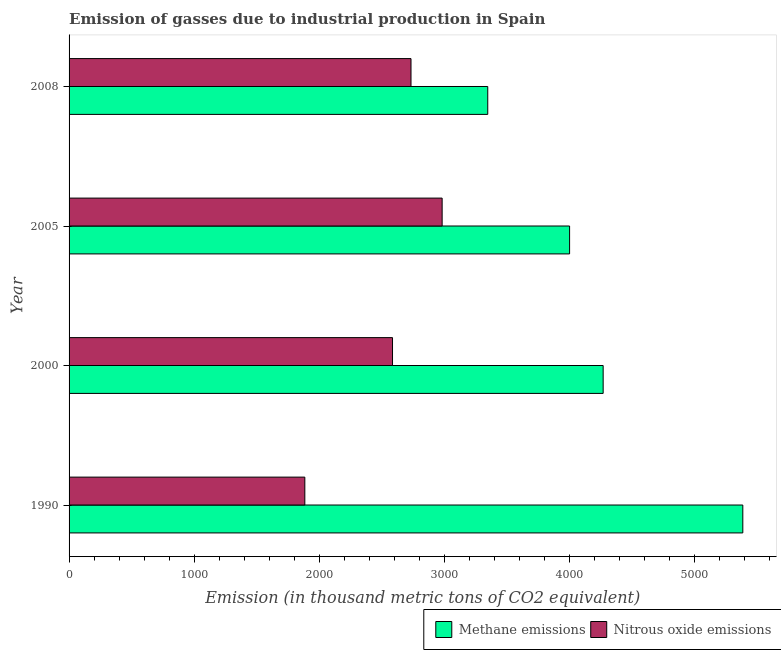How many groups of bars are there?
Give a very brief answer. 4. Are the number of bars per tick equal to the number of legend labels?
Your answer should be very brief. Yes. In how many cases, is the number of bars for a given year not equal to the number of legend labels?
Offer a terse response. 0. What is the amount of methane emissions in 1990?
Provide a short and direct response. 5387.8. Across all years, what is the maximum amount of nitrous oxide emissions?
Provide a short and direct response. 2983.4. Across all years, what is the minimum amount of nitrous oxide emissions?
Make the answer very short. 1885.3. In which year was the amount of nitrous oxide emissions minimum?
Your answer should be compact. 1990. What is the total amount of nitrous oxide emissions in the graph?
Your answer should be very brief. 1.02e+04. What is the difference between the amount of methane emissions in 1990 and that in 2008?
Keep it short and to the point. 2039.7. What is the difference between the amount of nitrous oxide emissions in 2005 and the amount of methane emissions in 1990?
Give a very brief answer. -2404.4. What is the average amount of methane emissions per year?
Provide a succinct answer. 4252.38. In the year 1990, what is the difference between the amount of methane emissions and amount of nitrous oxide emissions?
Your answer should be compact. 3502.5. In how many years, is the amount of methane emissions greater than 2600 thousand metric tons?
Your response must be concise. 4. What is the ratio of the amount of methane emissions in 2000 to that in 2008?
Offer a very short reply. 1.28. Is the difference between the amount of nitrous oxide emissions in 2000 and 2005 greater than the difference between the amount of methane emissions in 2000 and 2005?
Keep it short and to the point. No. What is the difference between the highest and the second highest amount of nitrous oxide emissions?
Provide a short and direct response. 249. What is the difference between the highest and the lowest amount of methane emissions?
Your answer should be very brief. 2039.7. In how many years, is the amount of methane emissions greater than the average amount of methane emissions taken over all years?
Give a very brief answer. 2. What does the 1st bar from the top in 2008 represents?
Provide a short and direct response. Nitrous oxide emissions. What does the 2nd bar from the bottom in 2000 represents?
Your answer should be compact. Nitrous oxide emissions. How many years are there in the graph?
Give a very brief answer. 4. What is the difference between two consecutive major ticks on the X-axis?
Your response must be concise. 1000. Are the values on the major ticks of X-axis written in scientific E-notation?
Your answer should be compact. No. How many legend labels are there?
Provide a short and direct response. 2. What is the title of the graph?
Provide a short and direct response. Emission of gasses due to industrial production in Spain. What is the label or title of the X-axis?
Make the answer very short. Emission (in thousand metric tons of CO2 equivalent). What is the Emission (in thousand metric tons of CO2 equivalent) of Methane emissions in 1990?
Provide a short and direct response. 5387.8. What is the Emission (in thousand metric tons of CO2 equivalent) in Nitrous oxide emissions in 1990?
Keep it short and to the point. 1885.3. What is the Emission (in thousand metric tons of CO2 equivalent) in Methane emissions in 2000?
Your response must be concise. 4271. What is the Emission (in thousand metric tons of CO2 equivalent) in Nitrous oxide emissions in 2000?
Your answer should be compact. 2586.5. What is the Emission (in thousand metric tons of CO2 equivalent) in Methane emissions in 2005?
Make the answer very short. 4002.6. What is the Emission (in thousand metric tons of CO2 equivalent) of Nitrous oxide emissions in 2005?
Your response must be concise. 2983.4. What is the Emission (in thousand metric tons of CO2 equivalent) in Methane emissions in 2008?
Offer a terse response. 3348.1. What is the Emission (in thousand metric tons of CO2 equivalent) in Nitrous oxide emissions in 2008?
Keep it short and to the point. 2734.4. Across all years, what is the maximum Emission (in thousand metric tons of CO2 equivalent) of Methane emissions?
Your answer should be compact. 5387.8. Across all years, what is the maximum Emission (in thousand metric tons of CO2 equivalent) in Nitrous oxide emissions?
Offer a terse response. 2983.4. Across all years, what is the minimum Emission (in thousand metric tons of CO2 equivalent) in Methane emissions?
Offer a terse response. 3348.1. Across all years, what is the minimum Emission (in thousand metric tons of CO2 equivalent) of Nitrous oxide emissions?
Offer a very short reply. 1885.3. What is the total Emission (in thousand metric tons of CO2 equivalent) of Methane emissions in the graph?
Provide a short and direct response. 1.70e+04. What is the total Emission (in thousand metric tons of CO2 equivalent) of Nitrous oxide emissions in the graph?
Make the answer very short. 1.02e+04. What is the difference between the Emission (in thousand metric tons of CO2 equivalent) in Methane emissions in 1990 and that in 2000?
Keep it short and to the point. 1116.8. What is the difference between the Emission (in thousand metric tons of CO2 equivalent) of Nitrous oxide emissions in 1990 and that in 2000?
Provide a short and direct response. -701.2. What is the difference between the Emission (in thousand metric tons of CO2 equivalent) of Methane emissions in 1990 and that in 2005?
Provide a succinct answer. 1385.2. What is the difference between the Emission (in thousand metric tons of CO2 equivalent) of Nitrous oxide emissions in 1990 and that in 2005?
Offer a terse response. -1098.1. What is the difference between the Emission (in thousand metric tons of CO2 equivalent) of Methane emissions in 1990 and that in 2008?
Your response must be concise. 2039.7. What is the difference between the Emission (in thousand metric tons of CO2 equivalent) of Nitrous oxide emissions in 1990 and that in 2008?
Your response must be concise. -849.1. What is the difference between the Emission (in thousand metric tons of CO2 equivalent) of Methane emissions in 2000 and that in 2005?
Your answer should be compact. 268.4. What is the difference between the Emission (in thousand metric tons of CO2 equivalent) of Nitrous oxide emissions in 2000 and that in 2005?
Your answer should be compact. -396.9. What is the difference between the Emission (in thousand metric tons of CO2 equivalent) of Methane emissions in 2000 and that in 2008?
Offer a very short reply. 922.9. What is the difference between the Emission (in thousand metric tons of CO2 equivalent) in Nitrous oxide emissions in 2000 and that in 2008?
Ensure brevity in your answer.  -147.9. What is the difference between the Emission (in thousand metric tons of CO2 equivalent) in Methane emissions in 2005 and that in 2008?
Give a very brief answer. 654.5. What is the difference between the Emission (in thousand metric tons of CO2 equivalent) in Nitrous oxide emissions in 2005 and that in 2008?
Make the answer very short. 249. What is the difference between the Emission (in thousand metric tons of CO2 equivalent) in Methane emissions in 1990 and the Emission (in thousand metric tons of CO2 equivalent) in Nitrous oxide emissions in 2000?
Give a very brief answer. 2801.3. What is the difference between the Emission (in thousand metric tons of CO2 equivalent) of Methane emissions in 1990 and the Emission (in thousand metric tons of CO2 equivalent) of Nitrous oxide emissions in 2005?
Your answer should be compact. 2404.4. What is the difference between the Emission (in thousand metric tons of CO2 equivalent) of Methane emissions in 1990 and the Emission (in thousand metric tons of CO2 equivalent) of Nitrous oxide emissions in 2008?
Offer a terse response. 2653.4. What is the difference between the Emission (in thousand metric tons of CO2 equivalent) in Methane emissions in 2000 and the Emission (in thousand metric tons of CO2 equivalent) in Nitrous oxide emissions in 2005?
Provide a succinct answer. 1287.6. What is the difference between the Emission (in thousand metric tons of CO2 equivalent) in Methane emissions in 2000 and the Emission (in thousand metric tons of CO2 equivalent) in Nitrous oxide emissions in 2008?
Provide a succinct answer. 1536.6. What is the difference between the Emission (in thousand metric tons of CO2 equivalent) in Methane emissions in 2005 and the Emission (in thousand metric tons of CO2 equivalent) in Nitrous oxide emissions in 2008?
Offer a terse response. 1268.2. What is the average Emission (in thousand metric tons of CO2 equivalent) in Methane emissions per year?
Ensure brevity in your answer.  4252.38. What is the average Emission (in thousand metric tons of CO2 equivalent) in Nitrous oxide emissions per year?
Provide a succinct answer. 2547.4. In the year 1990, what is the difference between the Emission (in thousand metric tons of CO2 equivalent) of Methane emissions and Emission (in thousand metric tons of CO2 equivalent) of Nitrous oxide emissions?
Offer a terse response. 3502.5. In the year 2000, what is the difference between the Emission (in thousand metric tons of CO2 equivalent) in Methane emissions and Emission (in thousand metric tons of CO2 equivalent) in Nitrous oxide emissions?
Provide a succinct answer. 1684.5. In the year 2005, what is the difference between the Emission (in thousand metric tons of CO2 equivalent) of Methane emissions and Emission (in thousand metric tons of CO2 equivalent) of Nitrous oxide emissions?
Make the answer very short. 1019.2. In the year 2008, what is the difference between the Emission (in thousand metric tons of CO2 equivalent) in Methane emissions and Emission (in thousand metric tons of CO2 equivalent) in Nitrous oxide emissions?
Your response must be concise. 613.7. What is the ratio of the Emission (in thousand metric tons of CO2 equivalent) in Methane emissions in 1990 to that in 2000?
Provide a succinct answer. 1.26. What is the ratio of the Emission (in thousand metric tons of CO2 equivalent) in Nitrous oxide emissions in 1990 to that in 2000?
Your answer should be very brief. 0.73. What is the ratio of the Emission (in thousand metric tons of CO2 equivalent) of Methane emissions in 1990 to that in 2005?
Ensure brevity in your answer.  1.35. What is the ratio of the Emission (in thousand metric tons of CO2 equivalent) of Nitrous oxide emissions in 1990 to that in 2005?
Ensure brevity in your answer.  0.63. What is the ratio of the Emission (in thousand metric tons of CO2 equivalent) in Methane emissions in 1990 to that in 2008?
Offer a terse response. 1.61. What is the ratio of the Emission (in thousand metric tons of CO2 equivalent) in Nitrous oxide emissions in 1990 to that in 2008?
Keep it short and to the point. 0.69. What is the ratio of the Emission (in thousand metric tons of CO2 equivalent) of Methane emissions in 2000 to that in 2005?
Provide a short and direct response. 1.07. What is the ratio of the Emission (in thousand metric tons of CO2 equivalent) of Nitrous oxide emissions in 2000 to that in 2005?
Your answer should be compact. 0.87. What is the ratio of the Emission (in thousand metric tons of CO2 equivalent) in Methane emissions in 2000 to that in 2008?
Make the answer very short. 1.28. What is the ratio of the Emission (in thousand metric tons of CO2 equivalent) in Nitrous oxide emissions in 2000 to that in 2008?
Your response must be concise. 0.95. What is the ratio of the Emission (in thousand metric tons of CO2 equivalent) in Methane emissions in 2005 to that in 2008?
Ensure brevity in your answer.  1.2. What is the ratio of the Emission (in thousand metric tons of CO2 equivalent) of Nitrous oxide emissions in 2005 to that in 2008?
Offer a terse response. 1.09. What is the difference between the highest and the second highest Emission (in thousand metric tons of CO2 equivalent) of Methane emissions?
Your response must be concise. 1116.8. What is the difference between the highest and the second highest Emission (in thousand metric tons of CO2 equivalent) of Nitrous oxide emissions?
Offer a terse response. 249. What is the difference between the highest and the lowest Emission (in thousand metric tons of CO2 equivalent) in Methane emissions?
Give a very brief answer. 2039.7. What is the difference between the highest and the lowest Emission (in thousand metric tons of CO2 equivalent) in Nitrous oxide emissions?
Make the answer very short. 1098.1. 